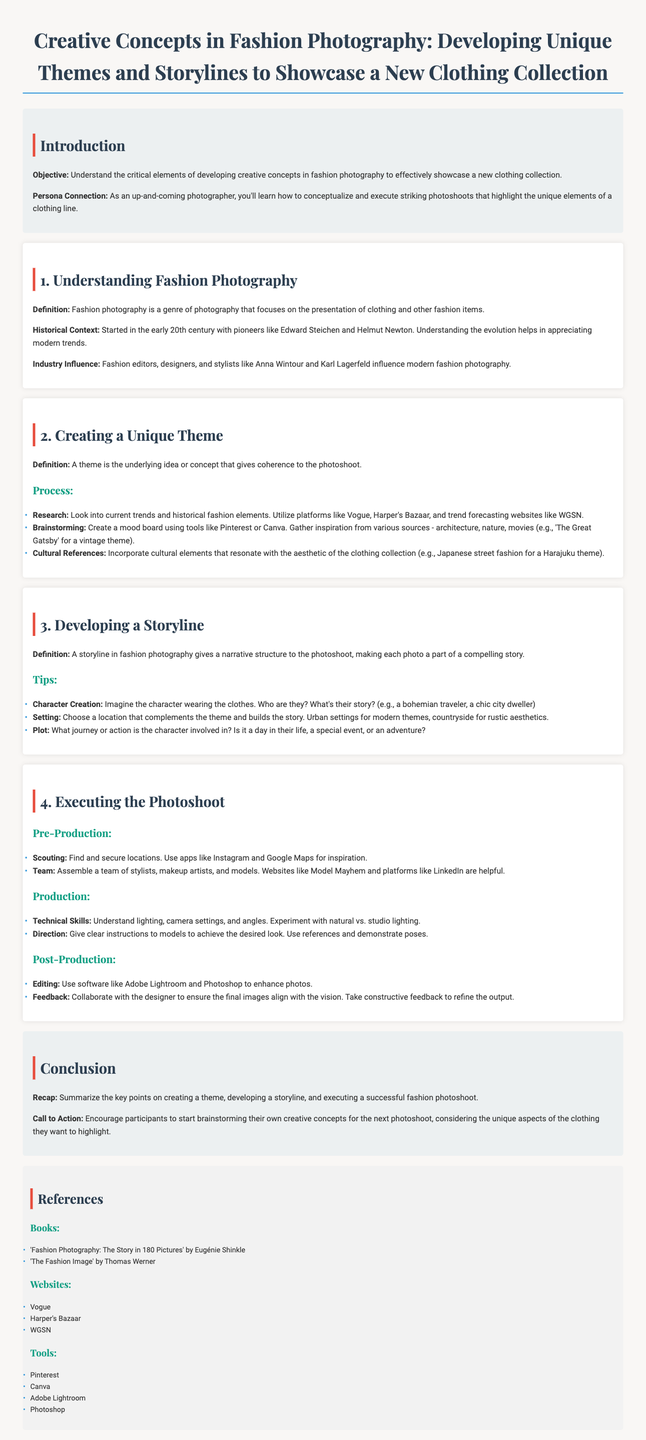What is the objective of the lesson? The objective is an understanding of the critical elements of developing creative concepts in fashion photography.
Answer: Understand the critical elements of developing creative concepts in fashion photography Who were some early pioneers of fashion photography mentioned? The document mentions key figures in the history of fashion photography for context.
Answer: Edward Steichen and Helmut Newton What tools can be used for brainstorming a theme? The document lists tools that help in creating a mood board for brainstorming themes.
Answer: Pinterest or Canva What role does character creation play in fashion photography? This asks for the significance of character development within the storyline of a photoshoot.
Answer: Gives a narrative structure to the photoshoot What should you research when creating a unique theme? The process of developing a theme outlines what to investigate for coherence.
Answer: Current trends and historical fashion elements What is the primary element needed for post-production? The document highlights important aspects needed after the photoshoot to refine images.
Answer: Editing What is one of the references listed in the document? This question asks for specific references provided to assist in learning more about fashion photography.
Answer: 'Fashion Photography: The Story in 180 Pictures' by Eugénie Shinkle What is the call to action in the conclusion? The conclusion encourages participants to take a specific step after the lesson.
Answer: Start brainstorming their own creative concepts What aspect of the clothing should the unique concepts highlight? This question centers around the focus for the upcoming photoshoot as mentioned in the conclusion.
Answer: Unique aspects of the clothing 